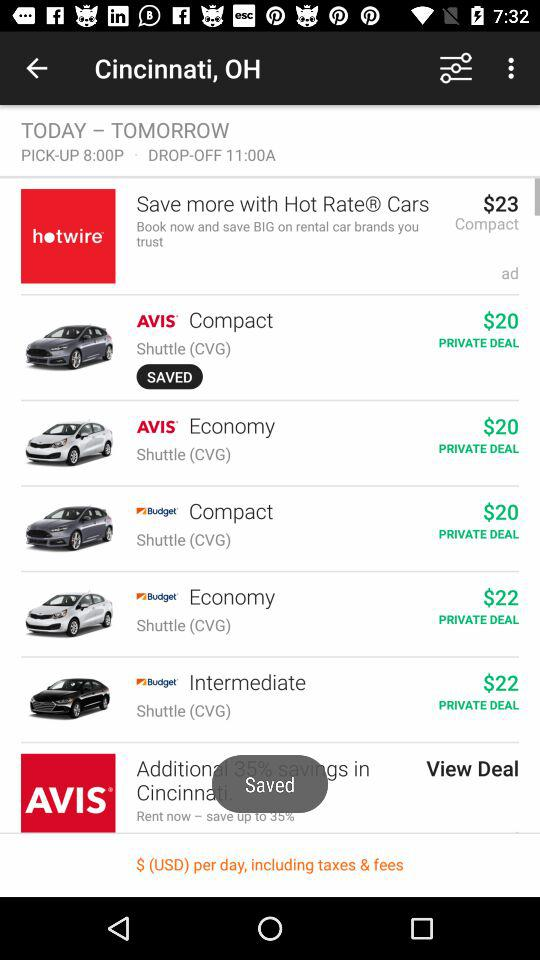What is the pick-up time? The pick-up time is 8:00 PM. 